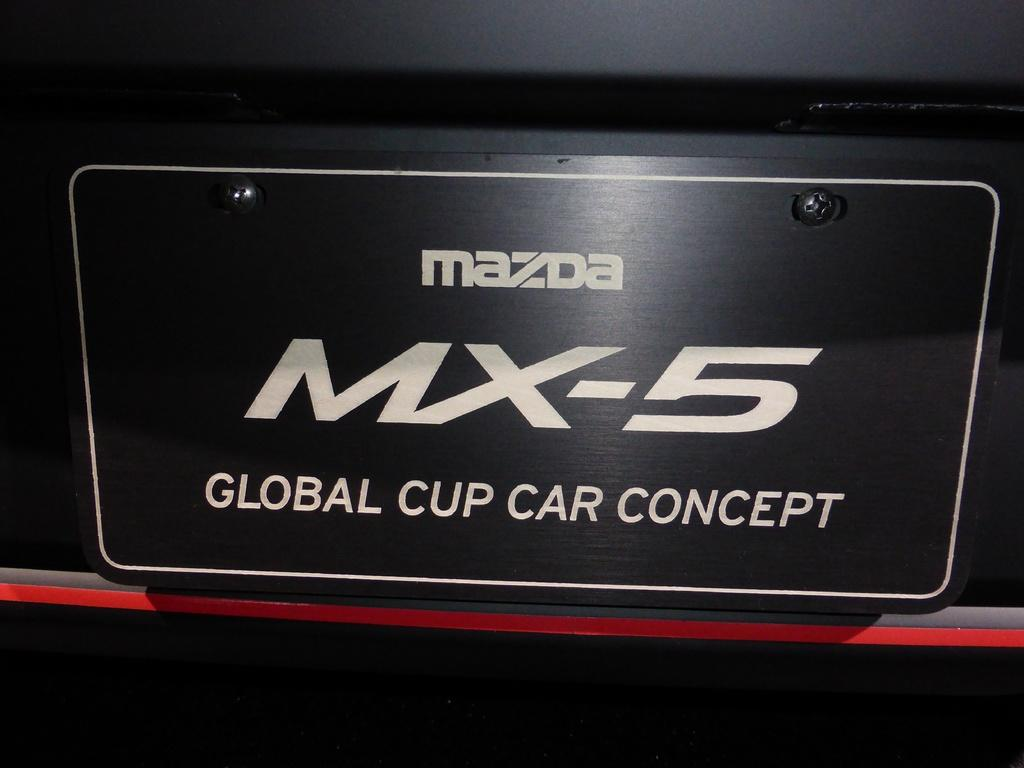What is the primary color of the board in the image? The primary color of the board in the image is black. What is written on the board, and what color is the text? The name is written in white color on the board. Are there any visible fasteners on the board? Yes, there are black color screws in the middle of the board. What type of rain gear is the fireman wearing in the image? There is no fireman or rain gear present in the image; it only features a black color board with a name written in white and black screws in the middle. 